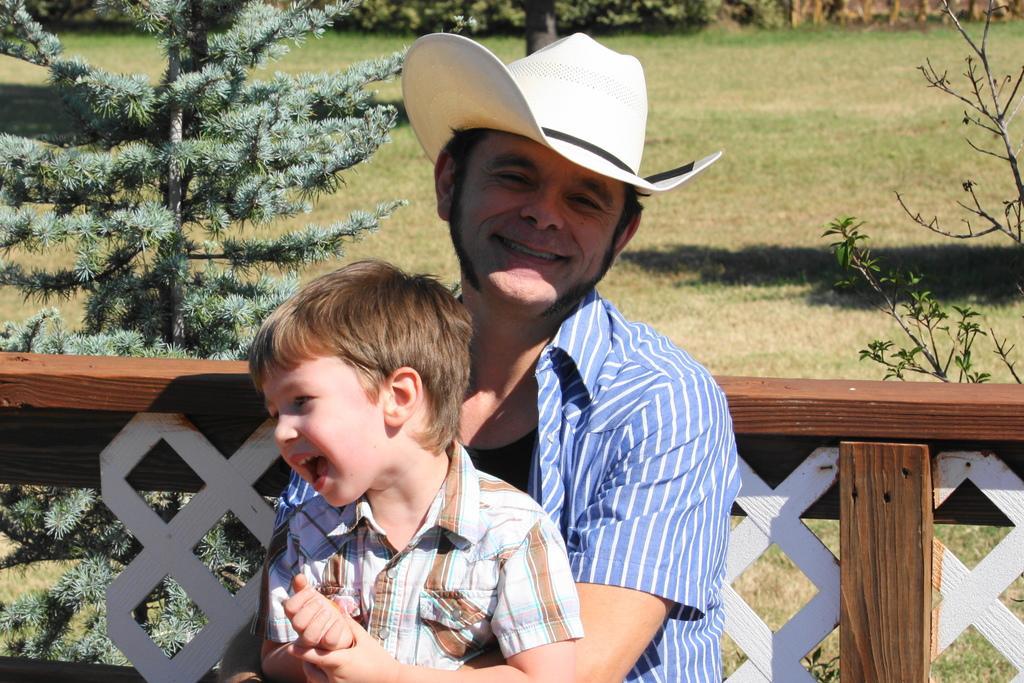How would you summarize this image in a sentence or two? In the center of the image we can see a man and kid. In the background we can see trees, fencing and grass. 